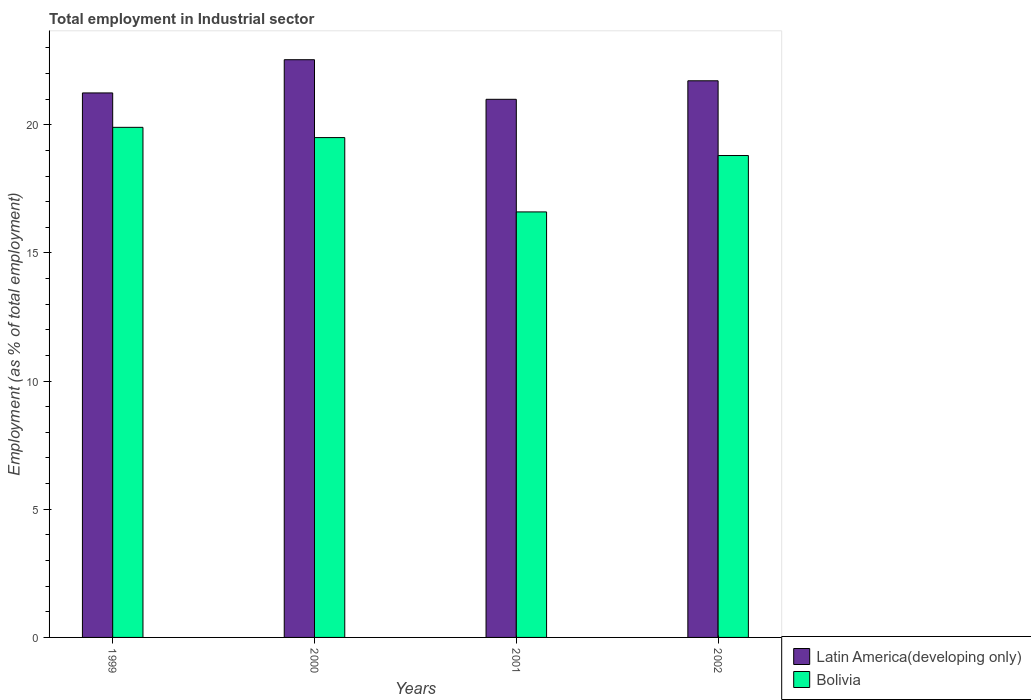How many groups of bars are there?
Make the answer very short. 4. How many bars are there on the 1st tick from the right?
Make the answer very short. 2. What is the label of the 3rd group of bars from the left?
Ensure brevity in your answer.  2001. In how many cases, is the number of bars for a given year not equal to the number of legend labels?
Offer a very short reply. 0. What is the employment in industrial sector in Bolivia in 2001?
Provide a succinct answer. 16.6. Across all years, what is the maximum employment in industrial sector in Bolivia?
Ensure brevity in your answer.  19.9. Across all years, what is the minimum employment in industrial sector in Bolivia?
Your answer should be very brief. 16.6. In which year was the employment in industrial sector in Bolivia maximum?
Offer a very short reply. 1999. In which year was the employment in industrial sector in Bolivia minimum?
Give a very brief answer. 2001. What is the total employment in industrial sector in Latin America(developing only) in the graph?
Give a very brief answer. 86.49. What is the difference between the employment in industrial sector in Bolivia in 1999 and that in 2002?
Your answer should be very brief. 1.1. What is the difference between the employment in industrial sector in Bolivia in 2000 and the employment in industrial sector in Latin America(developing only) in 2001?
Ensure brevity in your answer.  -1.49. What is the average employment in industrial sector in Bolivia per year?
Give a very brief answer. 18.7. In the year 2001, what is the difference between the employment in industrial sector in Latin America(developing only) and employment in industrial sector in Bolivia?
Keep it short and to the point. 4.39. In how many years, is the employment in industrial sector in Bolivia greater than 11 %?
Provide a succinct answer. 4. What is the ratio of the employment in industrial sector in Bolivia in 1999 to that in 2001?
Keep it short and to the point. 1.2. What is the difference between the highest and the second highest employment in industrial sector in Bolivia?
Provide a short and direct response. 0.4. What is the difference between the highest and the lowest employment in industrial sector in Latin America(developing only)?
Offer a terse response. 1.54. In how many years, is the employment in industrial sector in Bolivia greater than the average employment in industrial sector in Bolivia taken over all years?
Make the answer very short. 3. Is the sum of the employment in industrial sector in Latin America(developing only) in 1999 and 2000 greater than the maximum employment in industrial sector in Bolivia across all years?
Provide a succinct answer. Yes. What does the 2nd bar from the right in 1999 represents?
Your answer should be very brief. Latin America(developing only). What is the difference between two consecutive major ticks on the Y-axis?
Your answer should be very brief. 5. Are the values on the major ticks of Y-axis written in scientific E-notation?
Offer a very short reply. No. Does the graph contain grids?
Provide a short and direct response. No. How many legend labels are there?
Provide a succinct answer. 2. What is the title of the graph?
Offer a very short reply. Total employment in Industrial sector. What is the label or title of the Y-axis?
Offer a terse response. Employment (as % of total employment). What is the Employment (as % of total employment) in Latin America(developing only) in 1999?
Keep it short and to the point. 21.24. What is the Employment (as % of total employment) in Bolivia in 1999?
Make the answer very short. 19.9. What is the Employment (as % of total employment) of Latin America(developing only) in 2000?
Provide a succinct answer. 22.54. What is the Employment (as % of total employment) in Latin America(developing only) in 2001?
Your answer should be very brief. 20.99. What is the Employment (as % of total employment) of Bolivia in 2001?
Give a very brief answer. 16.6. What is the Employment (as % of total employment) of Latin America(developing only) in 2002?
Your answer should be very brief. 21.72. What is the Employment (as % of total employment) of Bolivia in 2002?
Offer a terse response. 18.8. Across all years, what is the maximum Employment (as % of total employment) in Latin America(developing only)?
Provide a short and direct response. 22.54. Across all years, what is the maximum Employment (as % of total employment) in Bolivia?
Offer a terse response. 19.9. Across all years, what is the minimum Employment (as % of total employment) in Latin America(developing only)?
Give a very brief answer. 20.99. Across all years, what is the minimum Employment (as % of total employment) in Bolivia?
Offer a terse response. 16.6. What is the total Employment (as % of total employment) of Latin America(developing only) in the graph?
Ensure brevity in your answer.  86.49. What is the total Employment (as % of total employment) in Bolivia in the graph?
Ensure brevity in your answer.  74.8. What is the difference between the Employment (as % of total employment) of Latin America(developing only) in 1999 and that in 2000?
Give a very brief answer. -1.3. What is the difference between the Employment (as % of total employment) in Bolivia in 1999 and that in 2000?
Offer a terse response. 0.4. What is the difference between the Employment (as % of total employment) in Latin America(developing only) in 1999 and that in 2001?
Offer a terse response. 0.25. What is the difference between the Employment (as % of total employment) in Latin America(developing only) in 1999 and that in 2002?
Make the answer very short. -0.47. What is the difference between the Employment (as % of total employment) of Latin America(developing only) in 2000 and that in 2001?
Ensure brevity in your answer.  1.54. What is the difference between the Employment (as % of total employment) in Bolivia in 2000 and that in 2001?
Keep it short and to the point. 2.9. What is the difference between the Employment (as % of total employment) of Latin America(developing only) in 2000 and that in 2002?
Offer a very short reply. 0.82. What is the difference between the Employment (as % of total employment) in Bolivia in 2000 and that in 2002?
Make the answer very short. 0.7. What is the difference between the Employment (as % of total employment) of Latin America(developing only) in 2001 and that in 2002?
Offer a terse response. -0.72. What is the difference between the Employment (as % of total employment) of Bolivia in 2001 and that in 2002?
Your answer should be compact. -2.2. What is the difference between the Employment (as % of total employment) of Latin America(developing only) in 1999 and the Employment (as % of total employment) of Bolivia in 2000?
Give a very brief answer. 1.74. What is the difference between the Employment (as % of total employment) of Latin America(developing only) in 1999 and the Employment (as % of total employment) of Bolivia in 2001?
Offer a very short reply. 4.64. What is the difference between the Employment (as % of total employment) in Latin America(developing only) in 1999 and the Employment (as % of total employment) in Bolivia in 2002?
Make the answer very short. 2.44. What is the difference between the Employment (as % of total employment) of Latin America(developing only) in 2000 and the Employment (as % of total employment) of Bolivia in 2001?
Offer a very short reply. 5.94. What is the difference between the Employment (as % of total employment) of Latin America(developing only) in 2000 and the Employment (as % of total employment) of Bolivia in 2002?
Your answer should be compact. 3.74. What is the difference between the Employment (as % of total employment) in Latin America(developing only) in 2001 and the Employment (as % of total employment) in Bolivia in 2002?
Make the answer very short. 2.19. What is the average Employment (as % of total employment) in Latin America(developing only) per year?
Make the answer very short. 21.62. What is the average Employment (as % of total employment) of Bolivia per year?
Keep it short and to the point. 18.7. In the year 1999, what is the difference between the Employment (as % of total employment) of Latin America(developing only) and Employment (as % of total employment) of Bolivia?
Offer a terse response. 1.34. In the year 2000, what is the difference between the Employment (as % of total employment) in Latin America(developing only) and Employment (as % of total employment) in Bolivia?
Make the answer very short. 3.04. In the year 2001, what is the difference between the Employment (as % of total employment) of Latin America(developing only) and Employment (as % of total employment) of Bolivia?
Your answer should be very brief. 4.39. In the year 2002, what is the difference between the Employment (as % of total employment) of Latin America(developing only) and Employment (as % of total employment) of Bolivia?
Offer a very short reply. 2.92. What is the ratio of the Employment (as % of total employment) of Latin America(developing only) in 1999 to that in 2000?
Your response must be concise. 0.94. What is the ratio of the Employment (as % of total employment) of Bolivia in 1999 to that in 2000?
Make the answer very short. 1.02. What is the ratio of the Employment (as % of total employment) in Latin America(developing only) in 1999 to that in 2001?
Make the answer very short. 1.01. What is the ratio of the Employment (as % of total employment) of Bolivia in 1999 to that in 2001?
Your answer should be very brief. 1.2. What is the ratio of the Employment (as % of total employment) of Latin America(developing only) in 1999 to that in 2002?
Keep it short and to the point. 0.98. What is the ratio of the Employment (as % of total employment) in Bolivia in 1999 to that in 2002?
Keep it short and to the point. 1.06. What is the ratio of the Employment (as % of total employment) of Latin America(developing only) in 2000 to that in 2001?
Your answer should be compact. 1.07. What is the ratio of the Employment (as % of total employment) in Bolivia in 2000 to that in 2001?
Offer a very short reply. 1.17. What is the ratio of the Employment (as % of total employment) of Latin America(developing only) in 2000 to that in 2002?
Offer a very short reply. 1.04. What is the ratio of the Employment (as % of total employment) of Bolivia in 2000 to that in 2002?
Make the answer very short. 1.04. What is the ratio of the Employment (as % of total employment) of Latin America(developing only) in 2001 to that in 2002?
Provide a succinct answer. 0.97. What is the ratio of the Employment (as % of total employment) of Bolivia in 2001 to that in 2002?
Offer a very short reply. 0.88. What is the difference between the highest and the second highest Employment (as % of total employment) of Latin America(developing only)?
Your response must be concise. 0.82. What is the difference between the highest and the second highest Employment (as % of total employment) in Bolivia?
Offer a terse response. 0.4. What is the difference between the highest and the lowest Employment (as % of total employment) in Latin America(developing only)?
Your response must be concise. 1.54. What is the difference between the highest and the lowest Employment (as % of total employment) of Bolivia?
Offer a very short reply. 3.3. 